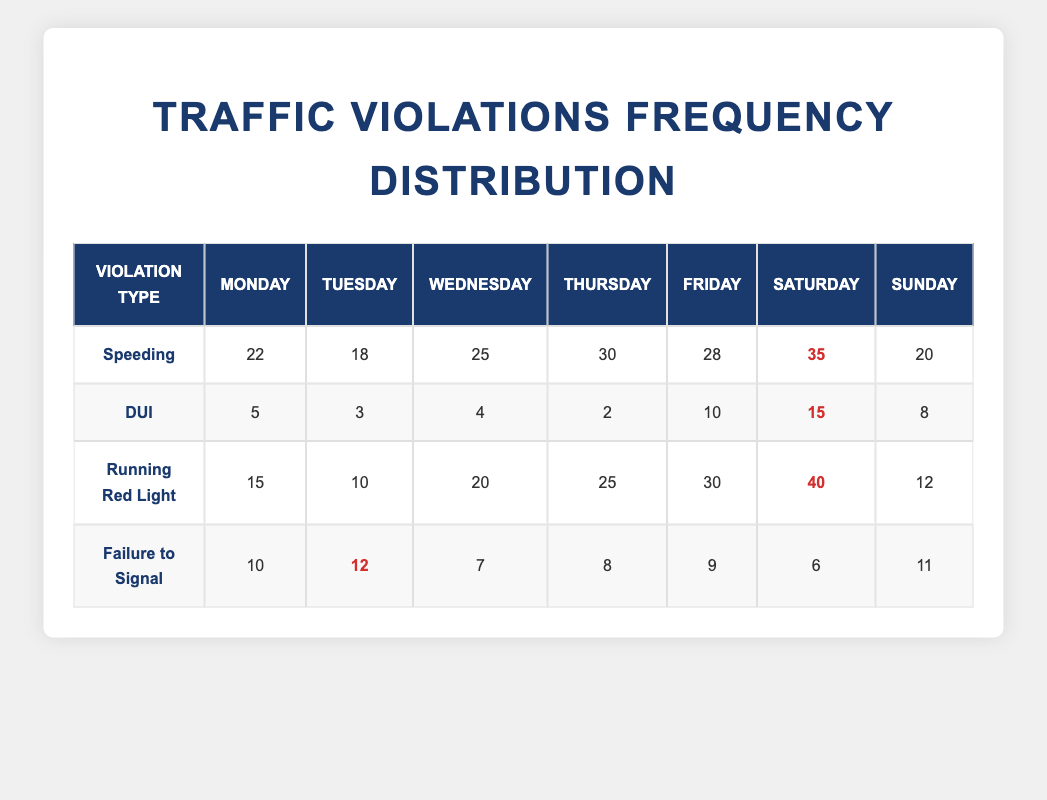What day has the highest number of speeding violations? Looking at the table, the highest speeding violations occur on Saturday with 35 instances. This is determined by comparing the speeding counts across all days and identifying the maximum value.
Answer: Saturday What day has the lowest number of DUI violations? From the table, Tuesday has the lowest DUI violations listed, with a count of 3. All the DUI numbers are compared, and Tuesday's value is confirmed as the smallest.
Answer: Tuesday What is the total number of running red light violations for the week? To find the total, sum up the running red light violations for each day: (15 + 10 + 20 + 25 + 30 + 40 + 12) = 152. Thus, the total for the week is 152.
Answer: 152 Which type of traffic violation has the highest total for the week? To determine the highest violation type, sum each type of violation over the week. Speeding totals to 150, DUI to 47, running red light to 152, and failure to signal to 63. The highest total is 152 for running red lights.
Answer: Running Red Light On which day did failure to signal violations reach the highest count? When examining the failure to signal counts, Tuesday has the highest count at 12. This was done by looking at the failure to signal entries per day and identifying the maximum.
Answer: Tuesday Was there any day where DUI violations were above 10? By inspecting the DUI counts, Friday and Saturday have DUI violations of 10 and 15 respectively, which are both above 10. Hence, the answer is yes.
Answer: Yes What is the average number of speeding violations per day across the week? The total speeding violations are calculated first (22 + 18 + 25 + 30 + 28 + 35 + 20) = 178. Since there are 7 days, the average is 178 / 7 = 25.43. So, rounding gives an average of about 25.
Answer: 25.43 Which traffic violation type had the highest number of violations on Thursday? From the table, on Thursday, running red light violations have the highest count at 25. This means looking at Thursday’s row and picking the value that stands out as the largest.
Answer: Running Red Light 